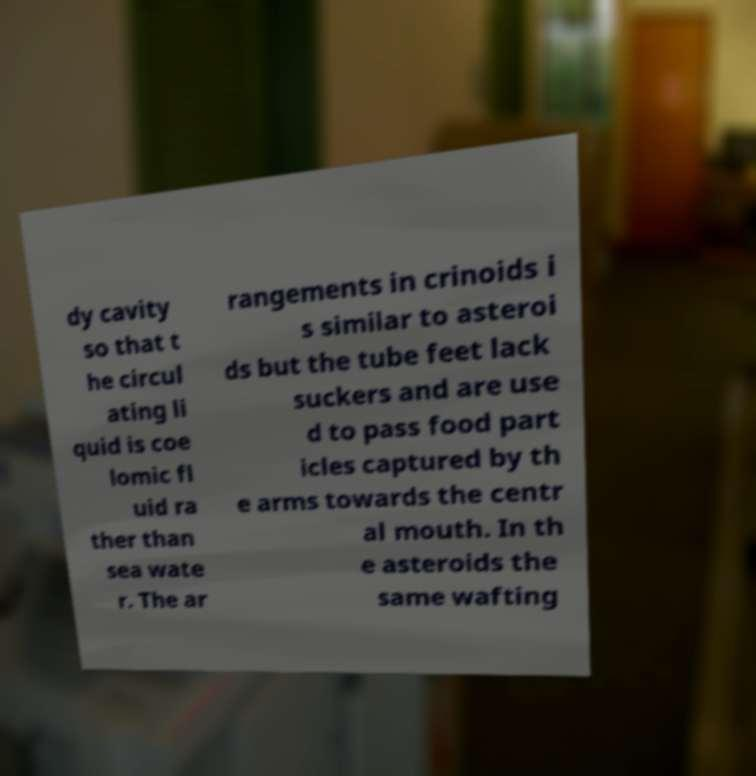Can you accurately transcribe the text from the provided image for me? dy cavity so that t he circul ating li quid is coe lomic fl uid ra ther than sea wate r. The ar rangements in crinoids i s similar to asteroi ds but the tube feet lack suckers and are use d to pass food part icles captured by th e arms towards the centr al mouth. In th e asteroids the same wafting 